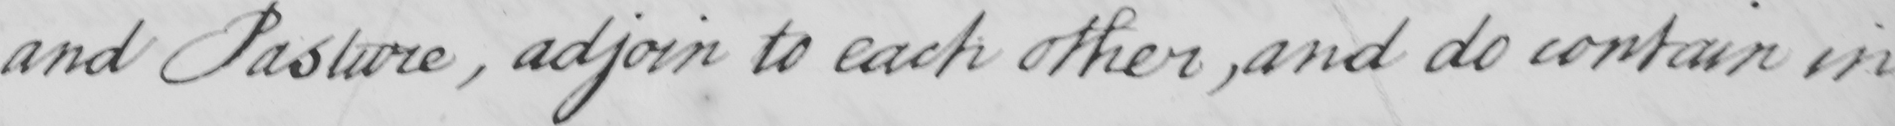Transcribe the text shown in this historical manuscript line. and Pasture  , adjoin to each other,and do contain in 